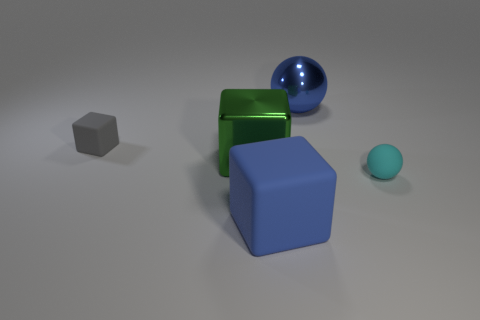What number of objects are rubber objects that are left of the big rubber block or large gray rubber spheres?
Provide a short and direct response. 1. How many other objects are there of the same color as the matte sphere?
Your answer should be very brief. 0. Is the number of blue metal things that are to the left of the blue matte cube the same as the number of green shiny things?
Your response must be concise. No. There is a large thing that is behind the small thing left of the blue matte block; what number of cyan rubber spheres are on the left side of it?
Your answer should be very brief. 0. Are there any other things that are the same size as the gray object?
Ensure brevity in your answer.  Yes. Does the green metallic cube have the same size as the rubber object that is behind the cyan thing?
Keep it short and to the point. No. How many things are there?
Your answer should be compact. 5. There is a ball in front of the big blue sphere; is it the same size as the gray rubber thing that is to the left of the green shiny cube?
Give a very brief answer. Yes. What color is the other small thing that is the same shape as the green object?
Your answer should be compact. Gray. Is the shape of the tiny gray object the same as the cyan object?
Provide a short and direct response. No. 